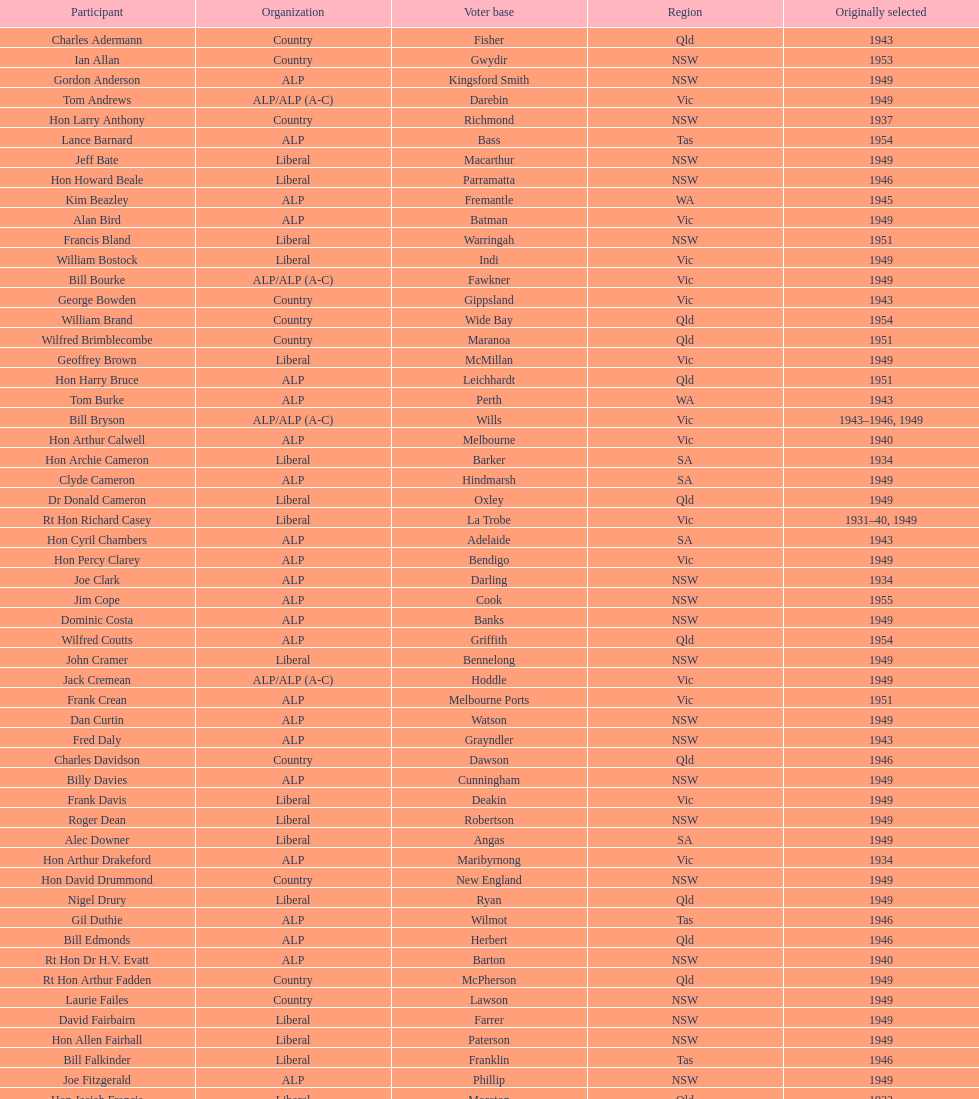When was joe clark first elected? 1934. 